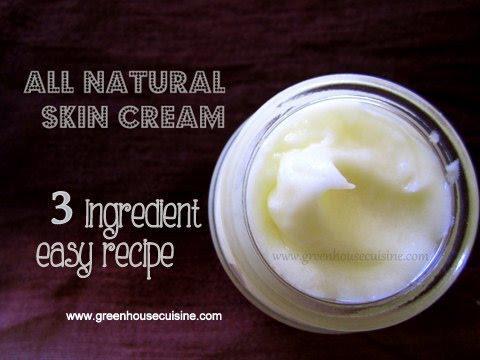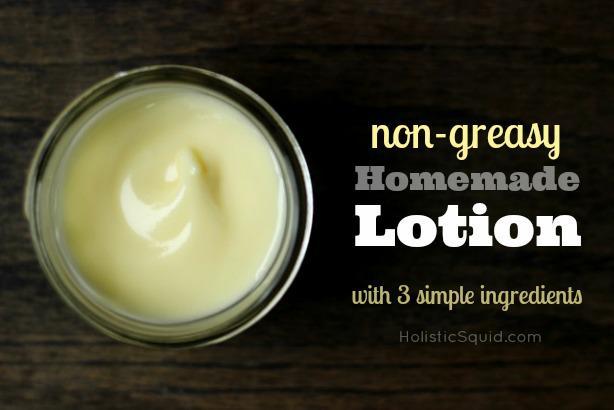The first image is the image on the left, the second image is the image on the right. For the images displayed, is the sentence "There is a white lotion in one image and a yellow lotion in the other." factually correct? Answer yes or no. Yes. 